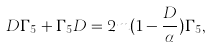<formula> <loc_0><loc_0><loc_500><loc_500>D \Gamma _ { 5 } + \Gamma _ { 5 } D = 2 m ( 1 - \frac { D } { \alpha } ) \Gamma _ { 5 } ,</formula> 